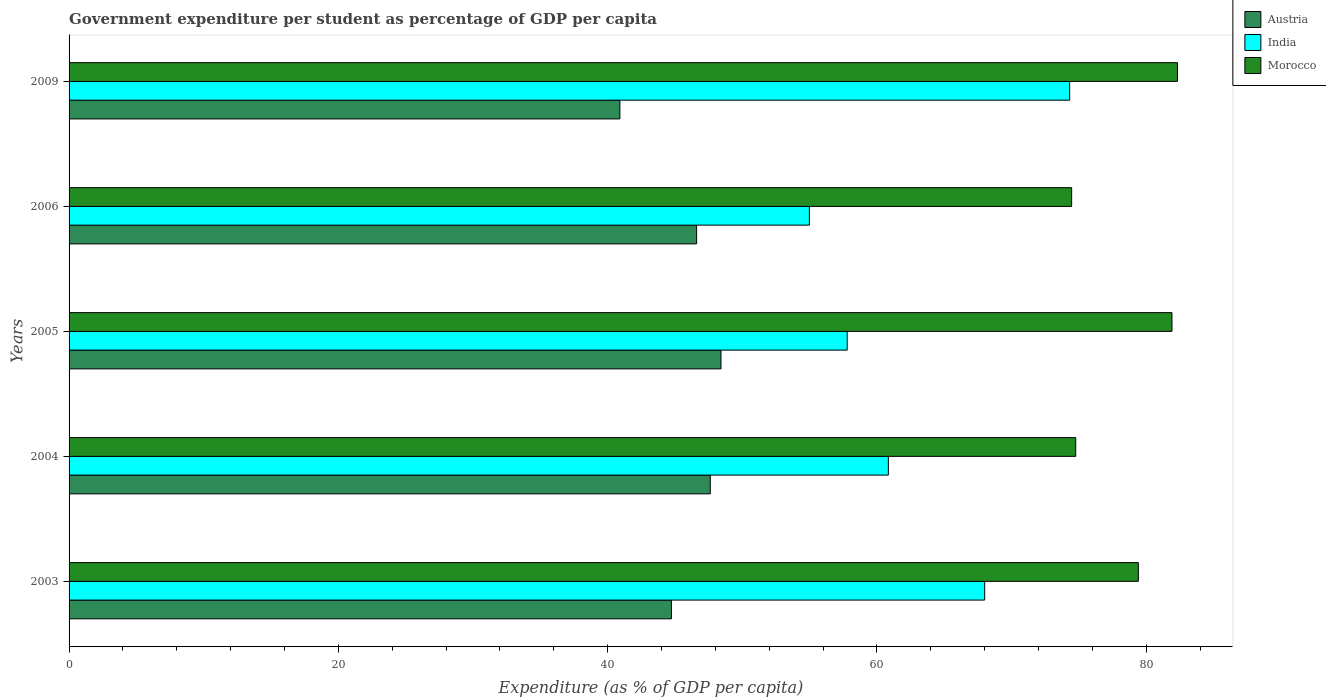Are the number of bars per tick equal to the number of legend labels?
Offer a terse response. Yes. Are the number of bars on each tick of the Y-axis equal?
Ensure brevity in your answer.  Yes. What is the percentage of expenditure per student in India in 2005?
Provide a short and direct response. 57.79. Across all years, what is the maximum percentage of expenditure per student in Austria?
Make the answer very short. 48.42. Across all years, what is the minimum percentage of expenditure per student in Morocco?
Your answer should be very brief. 74.46. In which year was the percentage of expenditure per student in India maximum?
Offer a very short reply. 2009. What is the total percentage of expenditure per student in Morocco in the graph?
Provide a short and direct response. 392.85. What is the difference between the percentage of expenditure per student in India in 2003 and that in 2005?
Your answer should be compact. 10.21. What is the difference between the percentage of expenditure per student in Morocco in 2005 and the percentage of expenditure per student in Austria in 2009?
Ensure brevity in your answer.  41. What is the average percentage of expenditure per student in Morocco per year?
Your response must be concise. 78.57. In the year 2004, what is the difference between the percentage of expenditure per student in Austria and percentage of expenditure per student in India?
Keep it short and to the point. -13.23. In how many years, is the percentage of expenditure per student in Morocco greater than 64 %?
Make the answer very short. 5. What is the ratio of the percentage of expenditure per student in India in 2006 to that in 2009?
Provide a short and direct response. 0.74. Is the percentage of expenditure per student in Morocco in 2003 less than that in 2006?
Your answer should be compact. No. What is the difference between the highest and the second highest percentage of expenditure per student in Austria?
Make the answer very short. 0.8. What is the difference between the highest and the lowest percentage of expenditure per student in India?
Provide a succinct answer. 19.33. In how many years, is the percentage of expenditure per student in Morocco greater than the average percentage of expenditure per student in Morocco taken over all years?
Your answer should be compact. 3. Is the sum of the percentage of expenditure per student in Morocco in 2004 and 2005 greater than the maximum percentage of expenditure per student in India across all years?
Ensure brevity in your answer.  Yes. What does the 1st bar from the top in 2009 represents?
Offer a terse response. Morocco. What does the 3rd bar from the bottom in 2005 represents?
Give a very brief answer. Morocco. Is it the case that in every year, the sum of the percentage of expenditure per student in India and percentage of expenditure per student in Austria is greater than the percentage of expenditure per student in Morocco?
Your answer should be compact. Yes. Where does the legend appear in the graph?
Make the answer very short. Top right. How many legend labels are there?
Give a very brief answer. 3. How are the legend labels stacked?
Provide a short and direct response. Vertical. What is the title of the graph?
Offer a terse response. Government expenditure per student as percentage of GDP per capita. What is the label or title of the X-axis?
Provide a succinct answer. Expenditure (as % of GDP per capita). What is the Expenditure (as % of GDP per capita) of Austria in 2003?
Ensure brevity in your answer.  44.73. What is the Expenditure (as % of GDP per capita) in India in 2003?
Ensure brevity in your answer.  68. What is the Expenditure (as % of GDP per capita) in Morocco in 2003?
Keep it short and to the point. 79.41. What is the Expenditure (as % of GDP per capita) in Austria in 2004?
Offer a terse response. 47.62. What is the Expenditure (as % of GDP per capita) of India in 2004?
Keep it short and to the point. 60.85. What is the Expenditure (as % of GDP per capita) in Morocco in 2004?
Offer a very short reply. 74.76. What is the Expenditure (as % of GDP per capita) in Austria in 2005?
Keep it short and to the point. 48.42. What is the Expenditure (as % of GDP per capita) of India in 2005?
Your answer should be very brief. 57.79. What is the Expenditure (as % of GDP per capita) of Morocco in 2005?
Provide a short and direct response. 81.91. What is the Expenditure (as % of GDP per capita) of Austria in 2006?
Your answer should be very brief. 46.61. What is the Expenditure (as % of GDP per capita) in India in 2006?
Your response must be concise. 54.98. What is the Expenditure (as % of GDP per capita) in Morocco in 2006?
Keep it short and to the point. 74.46. What is the Expenditure (as % of GDP per capita) of Austria in 2009?
Keep it short and to the point. 40.91. What is the Expenditure (as % of GDP per capita) of India in 2009?
Provide a succinct answer. 74.31. What is the Expenditure (as % of GDP per capita) in Morocco in 2009?
Ensure brevity in your answer.  82.31. Across all years, what is the maximum Expenditure (as % of GDP per capita) in Austria?
Ensure brevity in your answer.  48.42. Across all years, what is the maximum Expenditure (as % of GDP per capita) of India?
Your answer should be compact. 74.31. Across all years, what is the maximum Expenditure (as % of GDP per capita) in Morocco?
Your answer should be compact. 82.31. Across all years, what is the minimum Expenditure (as % of GDP per capita) of Austria?
Make the answer very short. 40.91. Across all years, what is the minimum Expenditure (as % of GDP per capita) in India?
Your answer should be compact. 54.98. Across all years, what is the minimum Expenditure (as % of GDP per capita) of Morocco?
Offer a very short reply. 74.46. What is the total Expenditure (as % of GDP per capita) in Austria in the graph?
Give a very brief answer. 228.28. What is the total Expenditure (as % of GDP per capita) of India in the graph?
Your answer should be compact. 315.92. What is the total Expenditure (as % of GDP per capita) in Morocco in the graph?
Keep it short and to the point. 392.85. What is the difference between the Expenditure (as % of GDP per capita) in Austria in 2003 and that in 2004?
Your response must be concise. -2.88. What is the difference between the Expenditure (as % of GDP per capita) of India in 2003 and that in 2004?
Keep it short and to the point. 7.15. What is the difference between the Expenditure (as % of GDP per capita) in Morocco in 2003 and that in 2004?
Ensure brevity in your answer.  4.65. What is the difference between the Expenditure (as % of GDP per capita) of Austria in 2003 and that in 2005?
Your response must be concise. -3.68. What is the difference between the Expenditure (as % of GDP per capita) of India in 2003 and that in 2005?
Your answer should be very brief. 10.21. What is the difference between the Expenditure (as % of GDP per capita) of Morocco in 2003 and that in 2005?
Keep it short and to the point. -2.5. What is the difference between the Expenditure (as % of GDP per capita) of Austria in 2003 and that in 2006?
Provide a short and direct response. -1.87. What is the difference between the Expenditure (as % of GDP per capita) of India in 2003 and that in 2006?
Provide a short and direct response. 13.02. What is the difference between the Expenditure (as % of GDP per capita) in Morocco in 2003 and that in 2006?
Give a very brief answer. 4.96. What is the difference between the Expenditure (as % of GDP per capita) of Austria in 2003 and that in 2009?
Make the answer very short. 3.83. What is the difference between the Expenditure (as % of GDP per capita) of India in 2003 and that in 2009?
Your answer should be compact. -6.31. What is the difference between the Expenditure (as % of GDP per capita) in Morocco in 2003 and that in 2009?
Offer a very short reply. -2.9. What is the difference between the Expenditure (as % of GDP per capita) of Austria in 2004 and that in 2005?
Ensure brevity in your answer.  -0.8. What is the difference between the Expenditure (as % of GDP per capita) of India in 2004 and that in 2005?
Your response must be concise. 3.06. What is the difference between the Expenditure (as % of GDP per capita) in Morocco in 2004 and that in 2005?
Your answer should be very brief. -7.15. What is the difference between the Expenditure (as % of GDP per capita) in Austria in 2004 and that in 2006?
Ensure brevity in your answer.  1.01. What is the difference between the Expenditure (as % of GDP per capita) of India in 2004 and that in 2006?
Offer a very short reply. 5.87. What is the difference between the Expenditure (as % of GDP per capita) of Morocco in 2004 and that in 2006?
Offer a terse response. 0.3. What is the difference between the Expenditure (as % of GDP per capita) of Austria in 2004 and that in 2009?
Offer a very short reply. 6.71. What is the difference between the Expenditure (as % of GDP per capita) of India in 2004 and that in 2009?
Your answer should be compact. -13.47. What is the difference between the Expenditure (as % of GDP per capita) in Morocco in 2004 and that in 2009?
Provide a succinct answer. -7.55. What is the difference between the Expenditure (as % of GDP per capita) in Austria in 2005 and that in 2006?
Your response must be concise. 1.81. What is the difference between the Expenditure (as % of GDP per capita) in India in 2005 and that in 2006?
Make the answer very short. 2.81. What is the difference between the Expenditure (as % of GDP per capita) of Morocco in 2005 and that in 2006?
Make the answer very short. 7.45. What is the difference between the Expenditure (as % of GDP per capita) in Austria in 2005 and that in 2009?
Your response must be concise. 7.51. What is the difference between the Expenditure (as % of GDP per capita) of India in 2005 and that in 2009?
Your response must be concise. -16.52. What is the difference between the Expenditure (as % of GDP per capita) in Morocco in 2005 and that in 2009?
Offer a very short reply. -0.41. What is the difference between the Expenditure (as % of GDP per capita) in Austria in 2006 and that in 2009?
Give a very brief answer. 5.7. What is the difference between the Expenditure (as % of GDP per capita) in India in 2006 and that in 2009?
Offer a very short reply. -19.33. What is the difference between the Expenditure (as % of GDP per capita) of Morocco in 2006 and that in 2009?
Your response must be concise. -7.86. What is the difference between the Expenditure (as % of GDP per capita) in Austria in 2003 and the Expenditure (as % of GDP per capita) in India in 2004?
Provide a short and direct response. -16.11. What is the difference between the Expenditure (as % of GDP per capita) of Austria in 2003 and the Expenditure (as % of GDP per capita) of Morocco in 2004?
Your response must be concise. -30.03. What is the difference between the Expenditure (as % of GDP per capita) in India in 2003 and the Expenditure (as % of GDP per capita) in Morocco in 2004?
Your response must be concise. -6.76. What is the difference between the Expenditure (as % of GDP per capita) in Austria in 2003 and the Expenditure (as % of GDP per capita) in India in 2005?
Provide a short and direct response. -13.05. What is the difference between the Expenditure (as % of GDP per capita) of Austria in 2003 and the Expenditure (as % of GDP per capita) of Morocco in 2005?
Provide a short and direct response. -37.17. What is the difference between the Expenditure (as % of GDP per capita) in India in 2003 and the Expenditure (as % of GDP per capita) in Morocco in 2005?
Your answer should be very brief. -13.91. What is the difference between the Expenditure (as % of GDP per capita) of Austria in 2003 and the Expenditure (as % of GDP per capita) of India in 2006?
Offer a very short reply. -10.24. What is the difference between the Expenditure (as % of GDP per capita) in Austria in 2003 and the Expenditure (as % of GDP per capita) in Morocco in 2006?
Make the answer very short. -29.72. What is the difference between the Expenditure (as % of GDP per capita) of India in 2003 and the Expenditure (as % of GDP per capita) of Morocco in 2006?
Provide a succinct answer. -6.46. What is the difference between the Expenditure (as % of GDP per capita) of Austria in 2003 and the Expenditure (as % of GDP per capita) of India in 2009?
Give a very brief answer. -29.58. What is the difference between the Expenditure (as % of GDP per capita) of Austria in 2003 and the Expenditure (as % of GDP per capita) of Morocco in 2009?
Provide a succinct answer. -37.58. What is the difference between the Expenditure (as % of GDP per capita) in India in 2003 and the Expenditure (as % of GDP per capita) in Morocco in 2009?
Ensure brevity in your answer.  -14.32. What is the difference between the Expenditure (as % of GDP per capita) of Austria in 2004 and the Expenditure (as % of GDP per capita) of India in 2005?
Offer a terse response. -10.17. What is the difference between the Expenditure (as % of GDP per capita) in Austria in 2004 and the Expenditure (as % of GDP per capita) in Morocco in 2005?
Provide a short and direct response. -34.29. What is the difference between the Expenditure (as % of GDP per capita) in India in 2004 and the Expenditure (as % of GDP per capita) in Morocco in 2005?
Ensure brevity in your answer.  -21.06. What is the difference between the Expenditure (as % of GDP per capita) in Austria in 2004 and the Expenditure (as % of GDP per capita) in India in 2006?
Your answer should be compact. -7.36. What is the difference between the Expenditure (as % of GDP per capita) of Austria in 2004 and the Expenditure (as % of GDP per capita) of Morocco in 2006?
Offer a very short reply. -26.84. What is the difference between the Expenditure (as % of GDP per capita) of India in 2004 and the Expenditure (as % of GDP per capita) of Morocco in 2006?
Your answer should be very brief. -13.61. What is the difference between the Expenditure (as % of GDP per capita) of Austria in 2004 and the Expenditure (as % of GDP per capita) of India in 2009?
Make the answer very short. -26.69. What is the difference between the Expenditure (as % of GDP per capita) of Austria in 2004 and the Expenditure (as % of GDP per capita) of Morocco in 2009?
Your answer should be very brief. -34.7. What is the difference between the Expenditure (as % of GDP per capita) of India in 2004 and the Expenditure (as % of GDP per capita) of Morocco in 2009?
Ensure brevity in your answer.  -21.47. What is the difference between the Expenditure (as % of GDP per capita) in Austria in 2005 and the Expenditure (as % of GDP per capita) in India in 2006?
Make the answer very short. -6.56. What is the difference between the Expenditure (as % of GDP per capita) of Austria in 2005 and the Expenditure (as % of GDP per capita) of Morocco in 2006?
Your answer should be very brief. -26.04. What is the difference between the Expenditure (as % of GDP per capita) of India in 2005 and the Expenditure (as % of GDP per capita) of Morocco in 2006?
Provide a short and direct response. -16.67. What is the difference between the Expenditure (as % of GDP per capita) in Austria in 2005 and the Expenditure (as % of GDP per capita) in India in 2009?
Give a very brief answer. -25.9. What is the difference between the Expenditure (as % of GDP per capita) in Austria in 2005 and the Expenditure (as % of GDP per capita) in Morocco in 2009?
Your answer should be very brief. -33.9. What is the difference between the Expenditure (as % of GDP per capita) of India in 2005 and the Expenditure (as % of GDP per capita) of Morocco in 2009?
Your answer should be compact. -24.52. What is the difference between the Expenditure (as % of GDP per capita) in Austria in 2006 and the Expenditure (as % of GDP per capita) in India in 2009?
Provide a short and direct response. -27.71. What is the difference between the Expenditure (as % of GDP per capita) of Austria in 2006 and the Expenditure (as % of GDP per capita) of Morocco in 2009?
Your answer should be very brief. -35.71. What is the difference between the Expenditure (as % of GDP per capita) of India in 2006 and the Expenditure (as % of GDP per capita) of Morocco in 2009?
Provide a succinct answer. -27.33. What is the average Expenditure (as % of GDP per capita) in Austria per year?
Offer a terse response. 45.66. What is the average Expenditure (as % of GDP per capita) of India per year?
Provide a succinct answer. 63.18. What is the average Expenditure (as % of GDP per capita) of Morocco per year?
Keep it short and to the point. 78.57. In the year 2003, what is the difference between the Expenditure (as % of GDP per capita) of Austria and Expenditure (as % of GDP per capita) of India?
Offer a very short reply. -23.26. In the year 2003, what is the difference between the Expenditure (as % of GDP per capita) in Austria and Expenditure (as % of GDP per capita) in Morocco?
Keep it short and to the point. -34.68. In the year 2003, what is the difference between the Expenditure (as % of GDP per capita) in India and Expenditure (as % of GDP per capita) in Morocco?
Your answer should be compact. -11.41. In the year 2004, what is the difference between the Expenditure (as % of GDP per capita) of Austria and Expenditure (as % of GDP per capita) of India?
Provide a short and direct response. -13.23. In the year 2004, what is the difference between the Expenditure (as % of GDP per capita) in Austria and Expenditure (as % of GDP per capita) in Morocco?
Your response must be concise. -27.14. In the year 2004, what is the difference between the Expenditure (as % of GDP per capita) in India and Expenditure (as % of GDP per capita) in Morocco?
Make the answer very short. -13.91. In the year 2005, what is the difference between the Expenditure (as % of GDP per capita) of Austria and Expenditure (as % of GDP per capita) of India?
Your answer should be compact. -9.37. In the year 2005, what is the difference between the Expenditure (as % of GDP per capita) in Austria and Expenditure (as % of GDP per capita) in Morocco?
Your answer should be very brief. -33.49. In the year 2005, what is the difference between the Expenditure (as % of GDP per capita) of India and Expenditure (as % of GDP per capita) of Morocco?
Your answer should be compact. -24.12. In the year 2006, what is the difference between the Expenditure (as % of GDP per capita) of Austria and Expenditure (as % of GDP per capita) of India?
Ensure brevity in your answer.  -8.37. In the year 2006, what is the difference between the Expenditure (as % of GDP per capita) in Austria and Expenditure (as % of GDP per capita) in Morocco?
Make the answer very short. -27.85. In the year 2006, what is the difference between the Expenditure (as % of GDP per capita) of India and Expenditure (as % of GDP per capita) of Morocco?
Make the answer very short. -19.48. In the year 2009, what is the difference between the Expenditure (as % of GDP per capita) of Austria and Expenditure (as % of GDP per capita) of India?
Your answer should be very brief. -33.4. In the year 2009, what is the difference between the Expenditure (as % of GDP per capita) of Austria and Expenditure (as % of GDP per capita) of Morocco?
Keep it short and to the point. -41.41. In the year 2009, what is the difference between the Expenditure (as % of GDP per capita) in India and Expenditure (as % of GDP per capita) in Morocco?
Give a very brief answer. -8. What is the ratio of the Expenditure (as % of GDP per capita) of Austria in 2003 to that in 2004?
Offer a terse response. 0.94. What is the ratio of the Expenditure (as % of GDP per capita) in India in 2003 to that in 2004?
Keep it short and to the point. 1.12. What is the ratio of the Expenditure (as % of GDP per capita) in Morocco in 2003 to that in 2004?
Offer a very short reply. 1.06. What is the ratio of the Expenditure (as % of GDP per capita) in Austria in 2003 to that in 2005?
Provide a short and direct response. 0.92. What is the ratio of the Expenditure (as % of GDP per capita) of India in 2003 to that in 2005?
Ensure brevity in your answer.  1.18. What is the ratio of the Expenditure (as % of GDP per capita) in Morocco in 2003 to that in 2005?
Provide a short and direct response. 0.97. What is the ratio of the Expenditure (as % of GDP per capita) of Austria in 2003 to that in 2006?
Ensure brevity in your answer.  0.96. What is the ratio of the Expenditure (as % of GDP per capita) in India in 2003 to that in 2006?
Offer a very short reply. 1.24. What is the ratio of the Expenditure (as % of GDP per capita) of Morocco in 2003 to that in 2006?
Your answer should be compact. 1.07. What is the ratio of the Expenditure (as % of GDP per capita) of Austria in 2003 to that in 2009?
Ensure brevity in your answer.  1.09. What is the ratio of the Expenditure (as % of GDP per capita) in India in 2003 to that in 2009?
Your response must be concise. 0.92. What is the ratio of the Expenditure (as % of GDP per capita) in Morocco in 2003 to that in 2009?
Ensure brevity in your answer.  0.96. What is the ratio of the Expenditure (as % of GDP per capita) in Austria in 2004 to that in 2005?
Your answer should be compact. 0.98. What is the ratio of the Expenditure (as % of GDP per capita) in India in 2004 to that in 2005?
Provide a short and direct response. 1.05. What is the ratio of the Expenditure (as % of GDP per capita) in Morocco in 2004 to that in 2005?
Your answer should be very brief. 0.91. What is the ratio of the Expenditure (as % of GDP per capita) of Austria in 2004 to that in 2006?
Offer a very short reply. 1.02. What is the ratio of the Expenditure (as % of GDP per capita) of India in 2004 to that in 2006?
Ensure brevity in your answer.  1.11. What is the ratio of the Expenditure (as % of GDP per capita) of Morocco in 2004 to that in 2006?
Your response must be concise. 1. What is the ratio of the Expenditure (as % of GDP per capita) in Austria in 2004 to that in 2009?
Your answer should be compact. 1.16. What is the ratio of the Expenditure (as % of GDP per capita) of India in 2004 to that in 2009?
Your response must be concise. 0.82. What is the ratio of the Expenditure (as % of GDP per capita) of Morocco in 2004 to that in 2009?
Give a very brief answer. 0.91. What is the ratio of the Expenditure (as % of GDP per capita) in Austria in 2005 to that in 2006?
Provide a succinct answer. 1.04. What is the ratio of the Expenditure (as % of GDP per capita) in India in 2005 to that in 2006?
Your answer should be compact. 1.05. What is the ratio of the Expenditure (as % of GDP per capita) in Morocco in 2005 to that in 2006?
Offer a terse response. 1.1. What is the ratio of the Expenditure (as % of GDP per capita) in Austria in 2005 to that in 2009?
Your response must be concise. 1.18. What is the ratio of the Expenditure (as % of GDP per capita) in India in 2005 to that in 2009?
Provide a short and direct response. 0.78. What is the ratio of the Expenditure (as % of GDP per capita) of Austria in 2006 to that in 2009?
Keep it short and to the point. 1.14. What is the ratio of the Expenditure (as % of GDP per capita) in India in 2006 to that in 2009?
Your answer should be very brief. 0.74. What is the ratio of the Expenditure (as % of GDP per capita) of Morocco in 2006 to that in 2009?
Keep it short and to the point. 0.9. What is the difference between the highest and the second highest Expenditure (as % of GDP per capita) in Austria?
Your answer should be very brief. 0.8. What is the difference between the highest and the second highest Expenditure (as % of GDP per capita) in India?
Keep it short and to the point. 6.31. What is the difference between the highest and the second highest Expenditure (as % of GDP per capita) in Morocco?
Give a very brief answer. 0.41. What is the difference between the highest and the lowest Expenditure (as % of GDP per capita) in Austria?
Provide a short and direct response. 7.51. What is the difference between the highest and the lowest Expenditure (as % of GDP per capita) of India?
Provide a short and direct response. 19.33. What is the difference between the highest and the lowest Expenditure (as % of GDP per capita) of Morocco?
Offer a terse response. 7.86. 